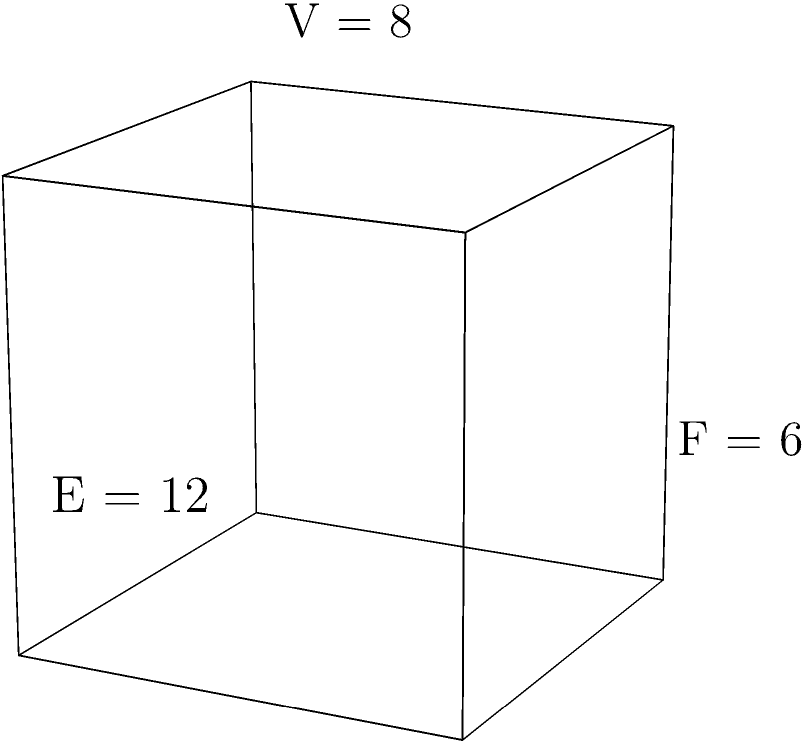As you sketch a design for a unique, cube-shaped meditation space for your sister's art class, you recall the Euler characteristic formula. Given that this polyhedron has 8 vertices, 12 edges, and 6 faces, calculate its Euler characteristic. How does this value relate to the topology of the shape? To solve this problem, we'll follow these steps:

1) Recall the Euler characteristic formula for polyhedra:
   $$\chi = V - E + F$$
   where $\chi$ is the Euler characteristic, $V$ is the number of vertices, $E$ is the number of edges, and $F$ is the number of faces.

2) We're given:
   $V = 8$ (vertices)
   $E = 12$ (edges)
   $F = 6$ (faces)

3) Let's substitute these values into the formula:
   $$\chi = 8 - 12 + 6$$

4) Simplify:
   $$\chi = 2$$

5) Interpret the result:
   The Euler characteristic of 2 is significant in topology. It indicates that this polyhedron is homeomorphic to a sphere, meaning it can be continuously deformed into a sphere without tearing or gluing. This is a property of all convex polyhedra, including the cube in this case.

6) Relation to topology:
   The Euler characteristic is a topological invariant, meaning it doesn't change under continuous deformations. All simply connected closed surfaces (like a sphere or any convex polyhedron) have an Euler characteristic of 2, regardless of their specific shape or the number of vertices, edges, or faces.
Answer: $\chi = 2$, indicating a sphere-like topology. 